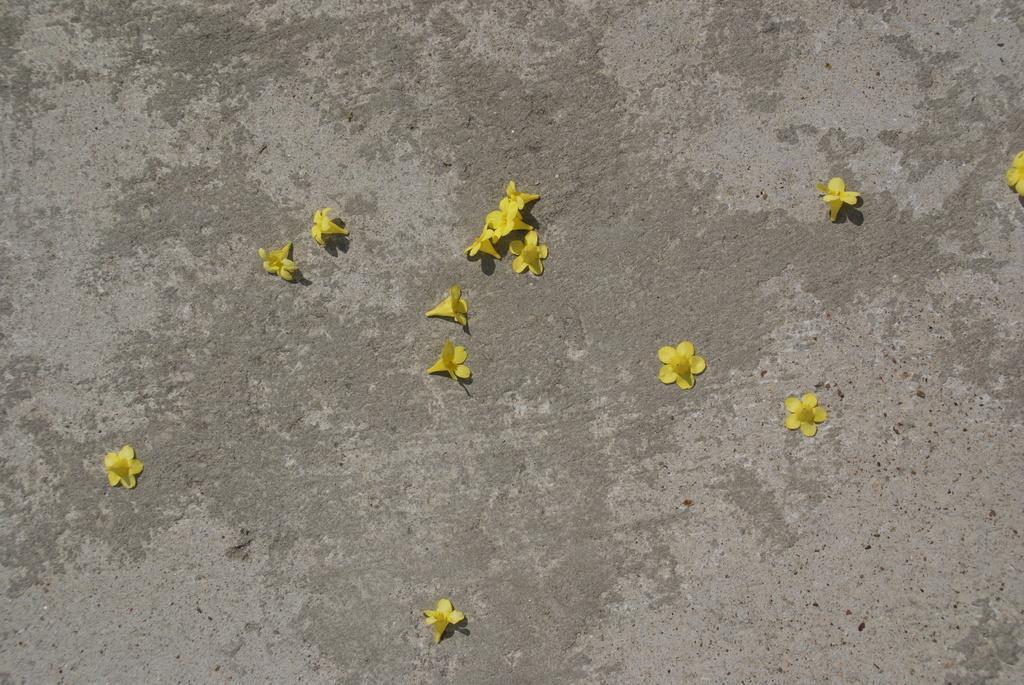Describe this image in one or two sentences. In this image we can see flowers which are in yellow color on the road. 